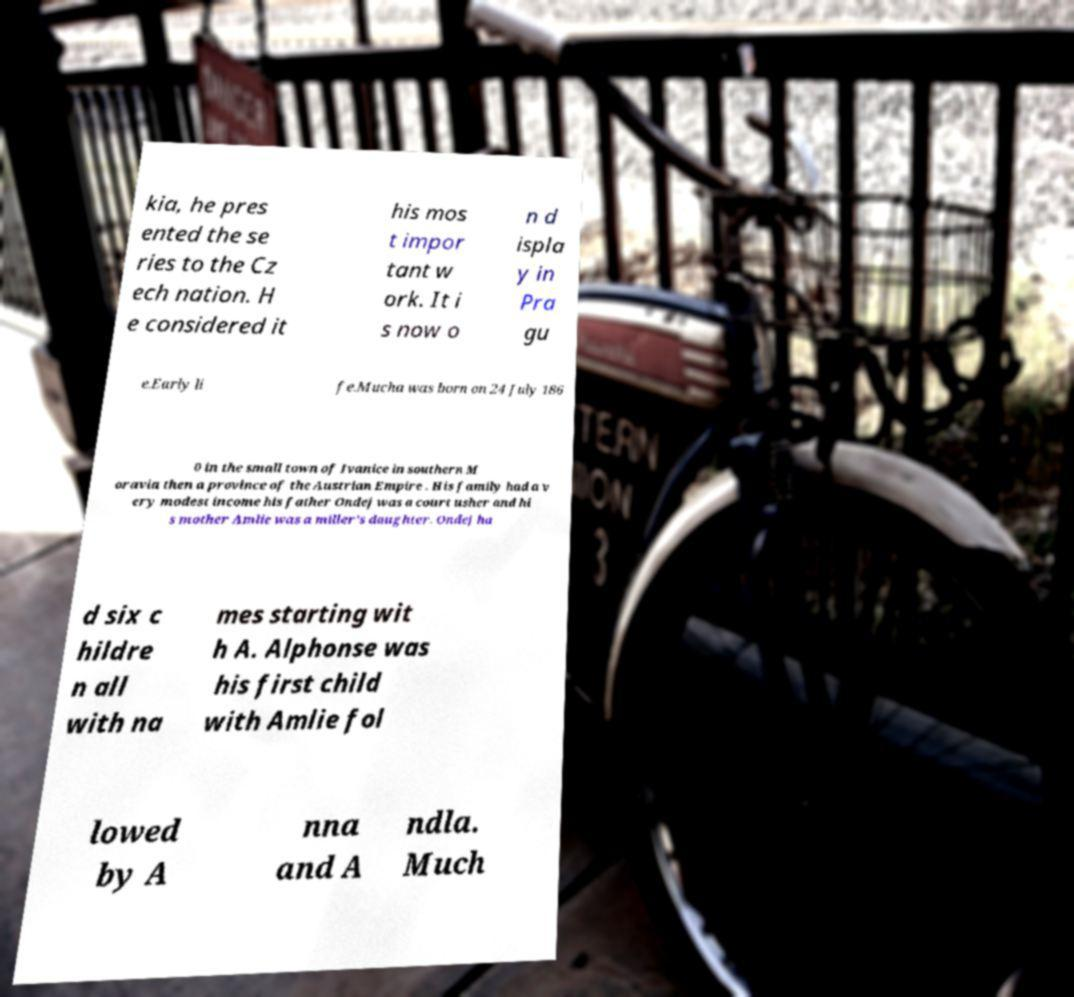There's text embedded in this image that I need extracted. Can you transcribe it verbatim? kia, he pres ented the se ries to the Cz ech nation. H e considered it his mos t impor tant w ork. It i s now o n d ispla y in Pra gu e.Early li fe.Mucha was born on 24 July 186 0 in the small town of Ivanice in southern M oravia then a province of the Austrian Empire . His family had a v ery modest income his father Ondej was a court usher and hi s mother Amlie was a miller's daughter. Ondej ha d six c hildre n all with na mes starting wit h A. Alphonse was his first child with Amlie fol lowed by A nna and A ndla. Much 